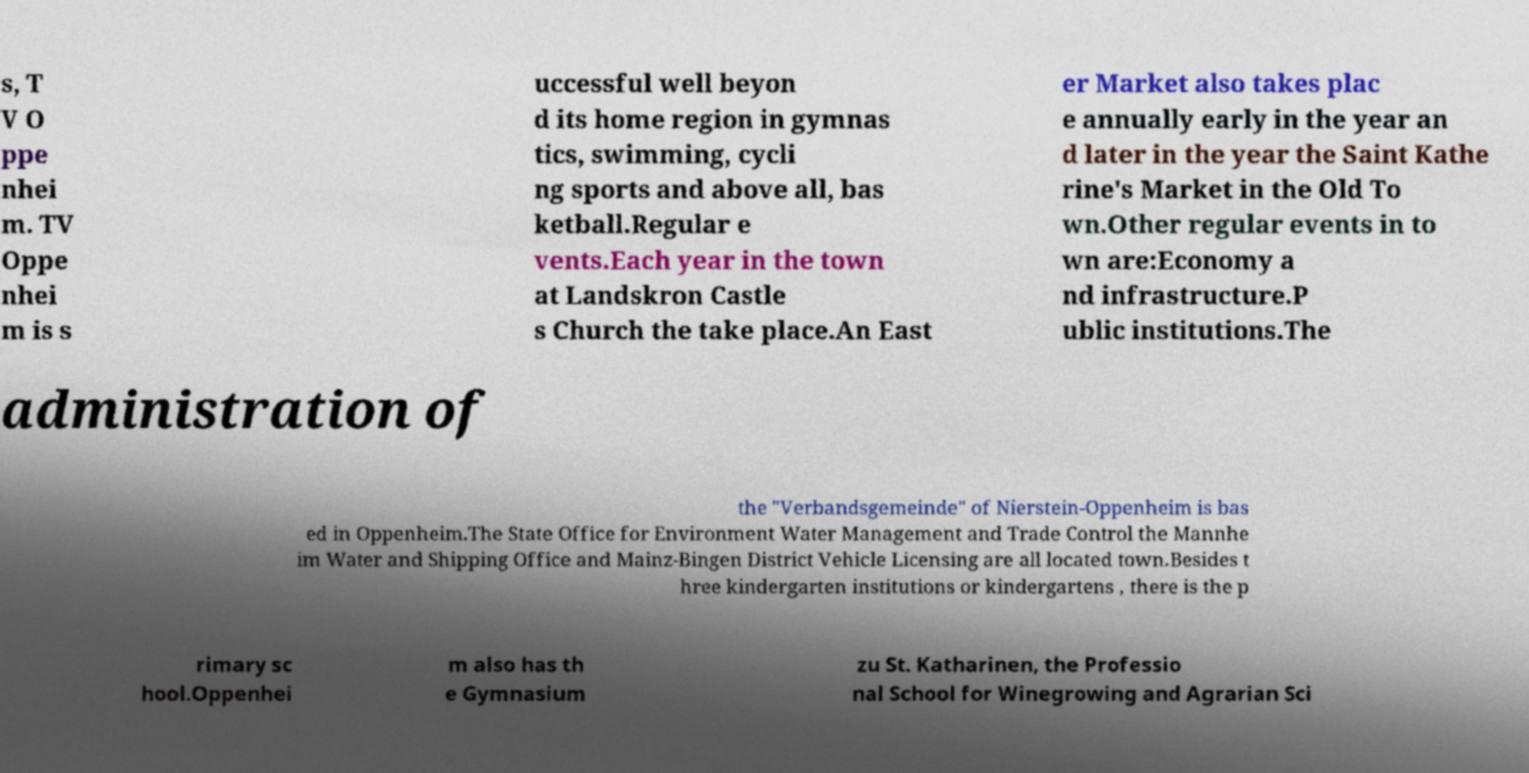What messages or text are displayed in this image? I need them in a readable, typed format. s, T V O ppe nhei m. TV Oppe nhei m is s uccessful well beyon d its home region in gymnas tics, swimming, cycli ng sports and above all, bas ketball.Regular e vents.Each year in the town at Landskron Castle s Church the take place.An East er Market also takes plac e annually early in the year an d later in the year the Saint Kathe rine's Market in the Old To wn.Other regular events in to wn are:Economy a nd infrastructure.P ublic institutions.The administration of the "Verbandsgemeinde" of Nierstein-Oppenheim is bas ed in Oppenheim.The State Office for Environment Water Management and Trade Control the Mannhe im Water and Shipping Office and Mainz-Bingen District Vehicle Licensing are all located town.Besides t hree kindergarten institutions or kindergartens , there is the p rimary sc hool.Oppenhei m also has th e Gymnasium zu St. Katharinen, the Professio nal School for Winegrowing and Agrarian Sci 